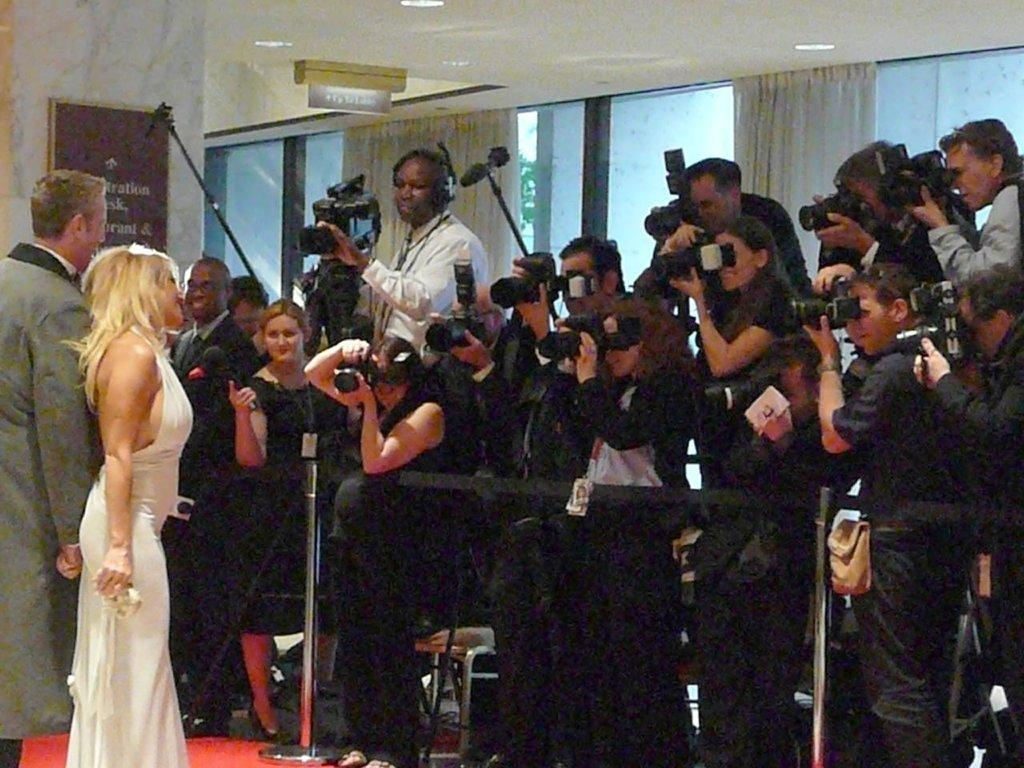Who are the two people standing in the image? There is a man and a woman standing in the image. What are the other people in the image doing? Many people are capturing them with cameras. What can be seen in the background of the image? There is a wall with a glass window in the background. Is there any window treatment present in the image? Yes, there is a curtain associated with the glass window in the background. What type of cap is the elbow wearing in the image? A: There is no elbow or cap present in the image. 